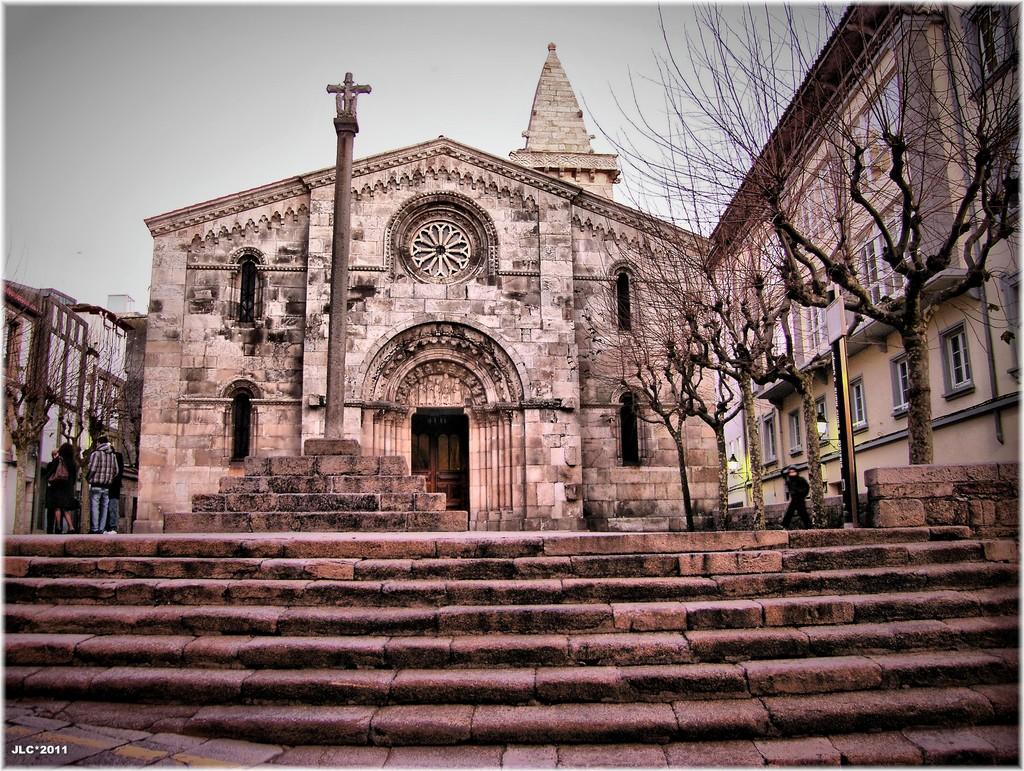Could you give a brief overview of what you see in this image? In this picture we can see some people are walking. In front of the people, there is a pillar, trees and buildings. Behind the buildings there is the sky. On the image there is a watermark. 